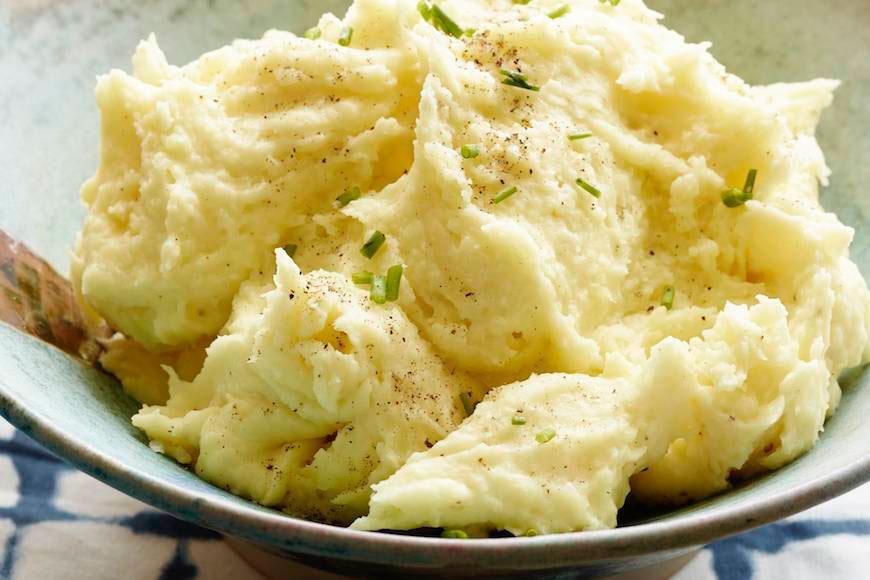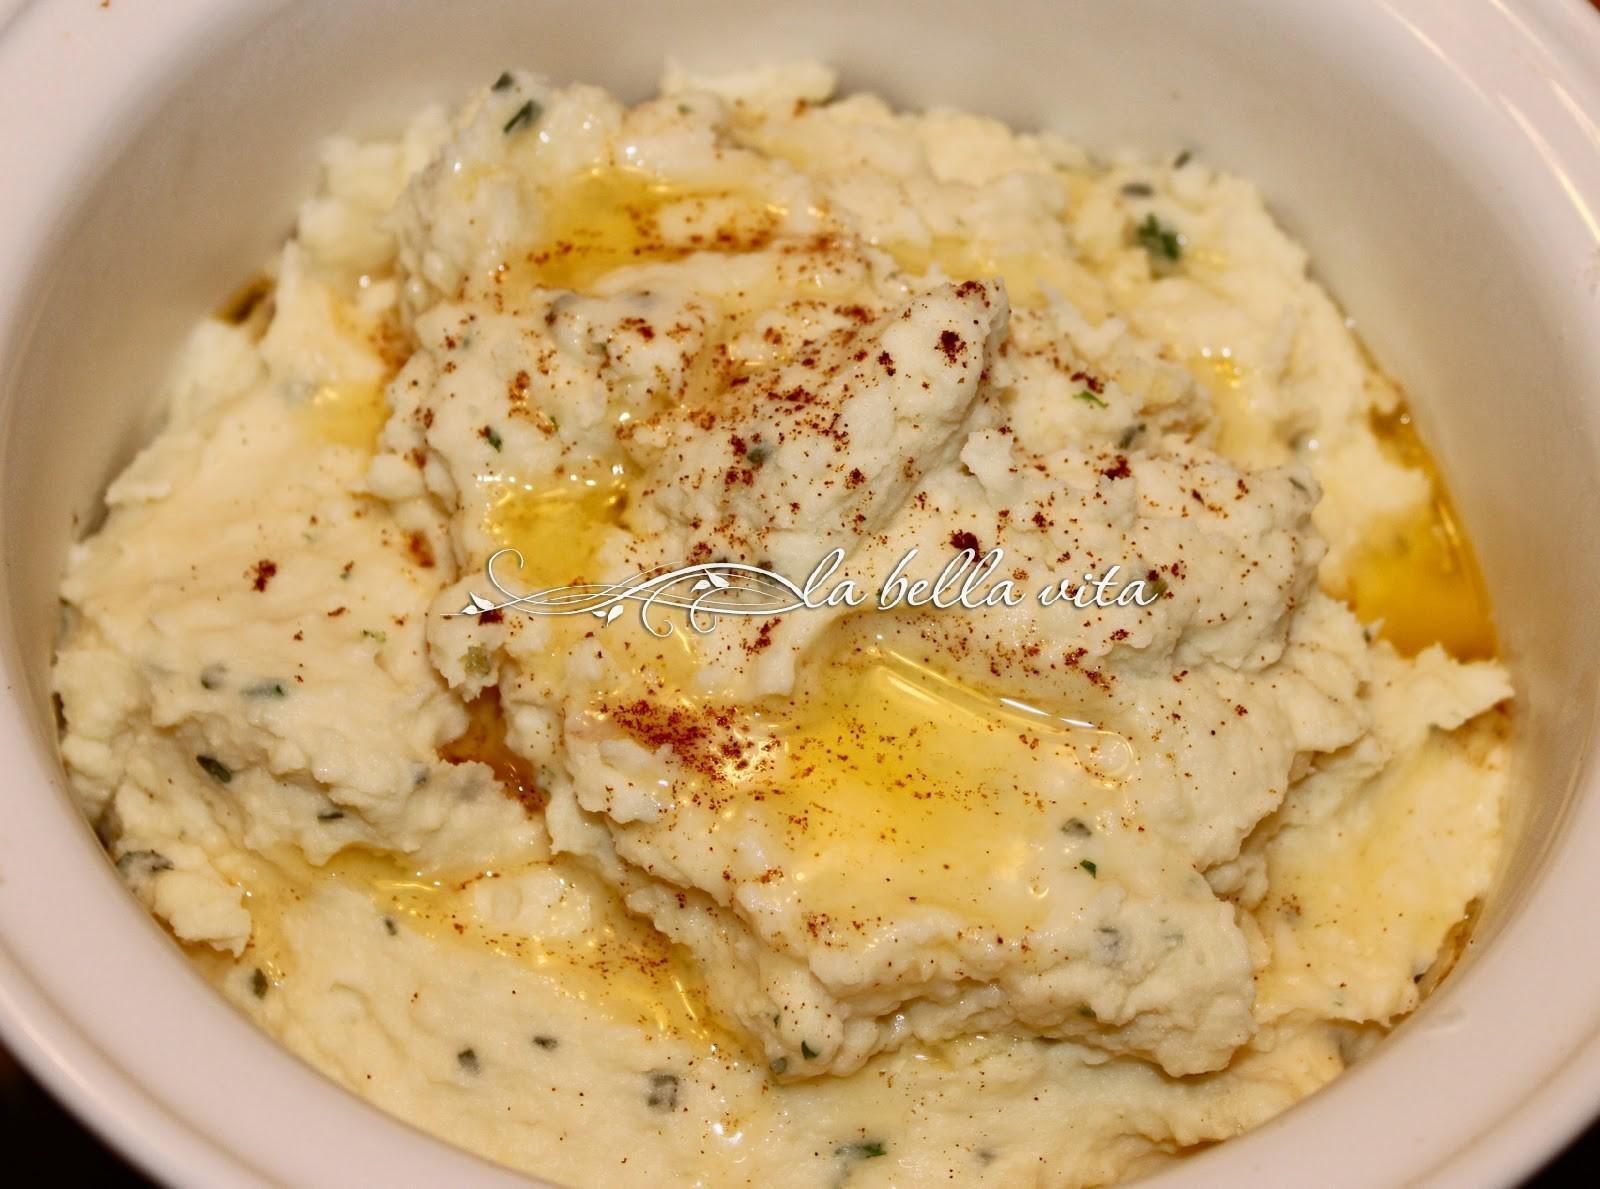The first image is the image on the left, the second image is the image on the right. Examine the images to the left and right. Is the description "The left image shows mashed potatoes in an oblong white bowl with cut-out handles." accurate? Answer yes or no. No. The first image is the image on the left, the second image is the image on the right. For the images shown, is this caption "The left and right image contains two round bowls with mash potatoes." true? Answer yes or no. Yes. 